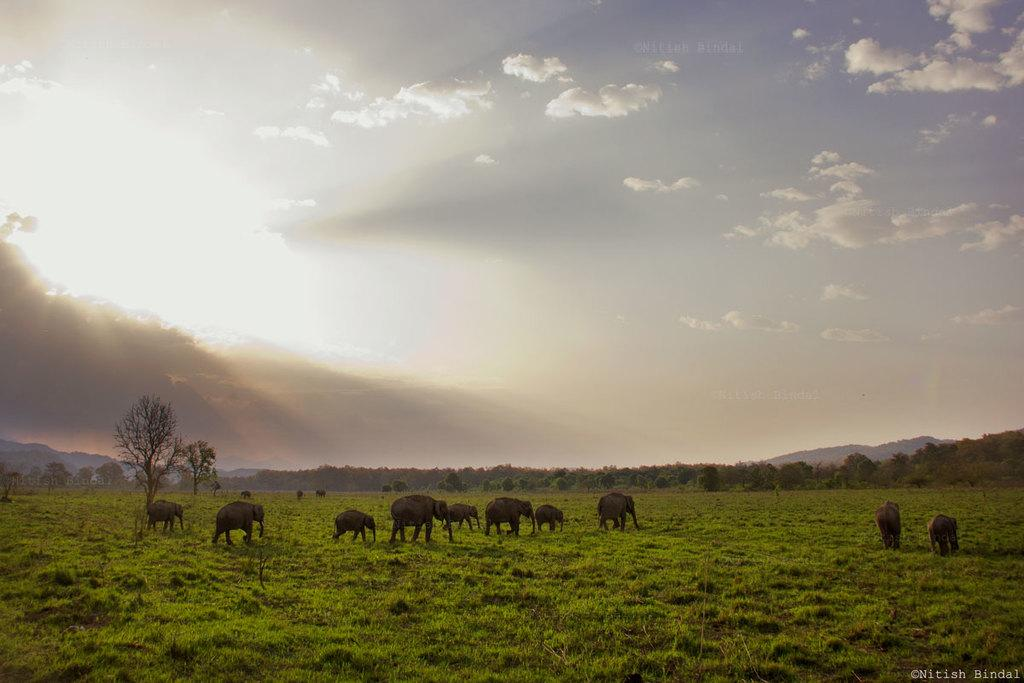What animals are at the bottom of the image? There are elephants at the bottom of the image. What can be seen in the background of the image? There are trees and a hill in the background of the image. What is visible in the sky in the image? The sky is visible in the background of the image. What theory is being demonstrated by the elephants in the image? There is no theory being demonstrated by the elephants in the image; they are simply depicted as part of the scene. Can you see any elephants kissing in the image? There is no indication of any elephants kissing in the image. 